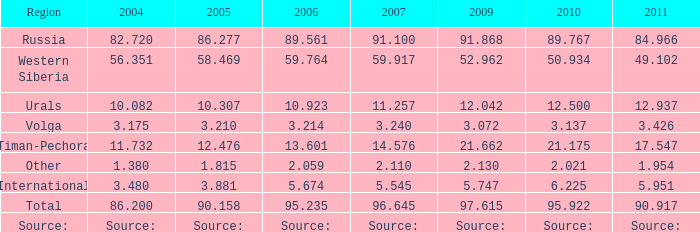What is the 2010 lukoil oil output when in 2009 oil output was 2 21.175. 